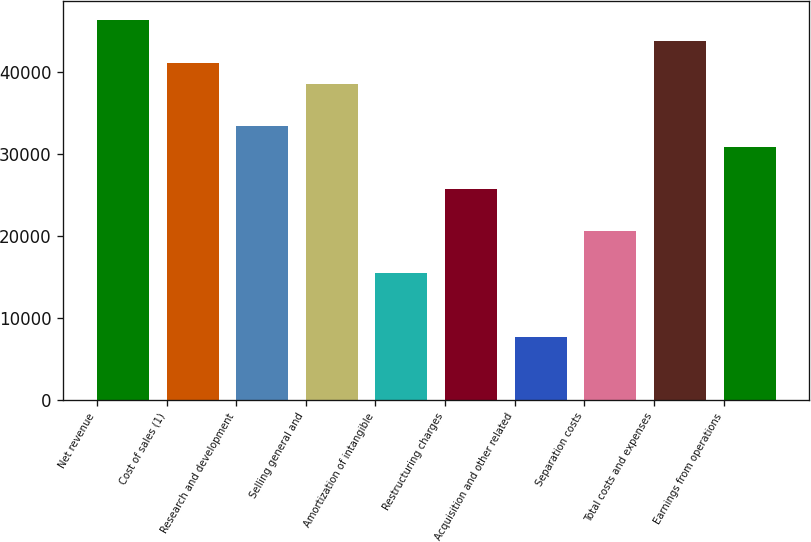<chart> <loc_0><loc_0><loc_500><loc_500><bar_chart><fcel>Net revenue<fcel>Cost of sales (1)<fcel>Research and development<fcel>Selling general and<fcel>Amortization of intangible<fcel>Restructuring charges<fcel>Acquisition and other related<fcel>Separation costs<fcel>Total costs and expenses<fcel>Earnings from operations<nl><fcel>46285<fcel>41142.3<fcel>33428.1<fcel>38570.9<fcel>15428.5<fcel>25714<fcel>7714.32<fcel>20571.2<fcel>43713.6<fcel>30856.7<nl></chart> 